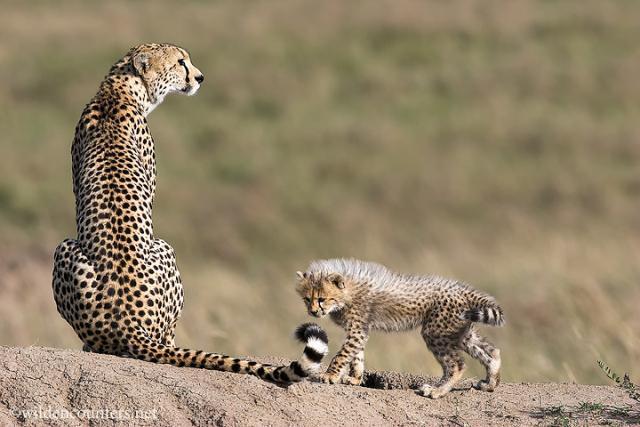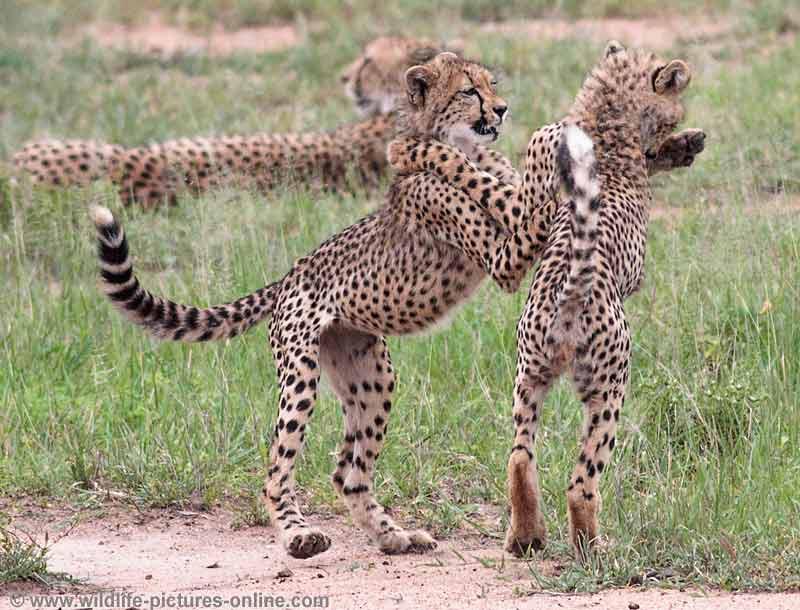The first image is the image on the left, the second image is the image on the right. Evaluate the accuracy of this statement regarding the images: "There is one cheetah in the left image and two cheetahs in the right image". Is it true? Answer yes or no. No. 